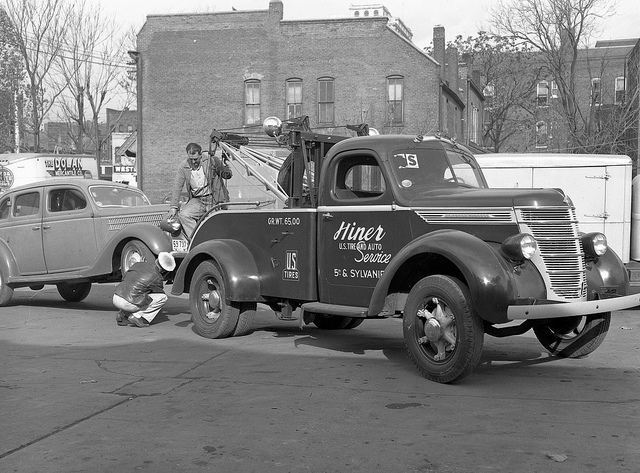Please identify all text content in this image. Hiner SYLVANIO S AUTO 6 THE US GAME 35 DOLAR 